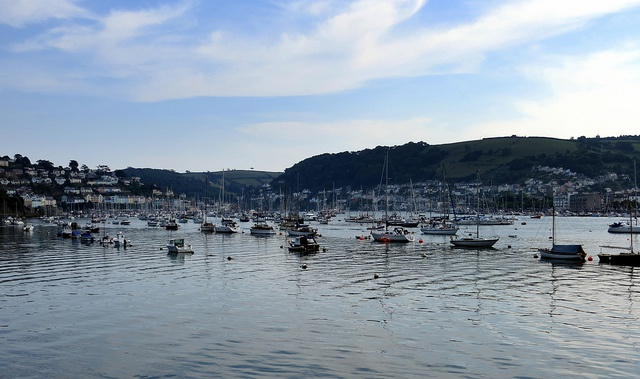Describe the objects in this image and their specific colors. I can see boat in darkgray, gray, and black tones, boat in darkgray, black, navy, blue, and gray tones, boat in darkgray, black, gray, and blue tones, boat in darkgray, black, gray, and darkblue tones, and boat in darkgray, black, gray, and darkblue tones in this image. 